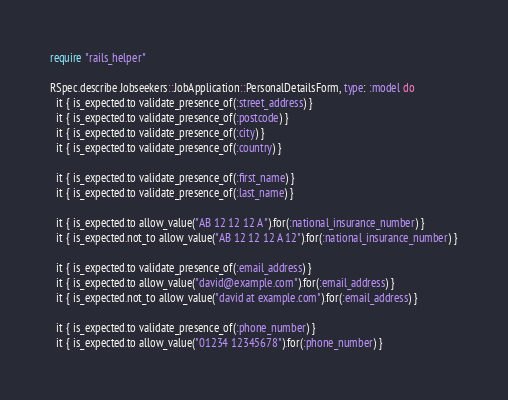Convert code to text. <code><loc_0><loc_0><loc_500><loc_500><_Ruby_>require "rails_helper"

RSpec.describe Jobseekers::JobApplication::PersonalDetailsForm, type: :model do
  it { is_expected.to validate_presence_of(:street_address) }
  it { is_expected.to validate_presence_of(:postcode) }
  it { is_expected.to validate_presence_of(:city) }
  it { is_expected.to validate_presence_of(:country) }

  it { is_expected.to validate_presence_of(:first_name) }
  it { is_expected.to validate_presence_of(:last_name) }

  it { is_expected.to allow_value("AB 12 12 12 A").for(:national_insurance_number) }
  it { is_expected.not_to allow_value("AB 12 12 12 A 12").for(:national_insurance_number) }

  it { is_expected.to validate_presence_of(:email_address) }
  it { is_expected.to allow_value("david@example.com").for(:email_address) }
  it { is_expected.not_to allow_value("david at example.com").for(:email_address) }

  it { is_expected.to validate_presence_of(:phone_number) }
  it { is_expected.to allow_value("01234 12345678").for(:phone_number) }</code> 